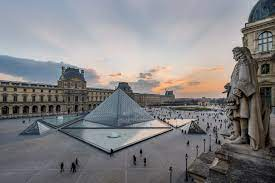What is this photo about? This captivating photograph presents an aerial view of the iconic courtyard of the Louvre Museum in Paris, under the soft glow of twilight. It highlights the striking glass pyramid, an avant-garde emblem set against the historic backdrop of the museum's classical architecture. Visitors appear as tiny specks, offering a sense of scale and liveliness to the ensemble. The tranquility of the evening sky, adorned with delicate clouds, brings a serene ambiance to this cultural epicenter, inviting onlookers to contemplate the harmonious blend of history and modernity. 